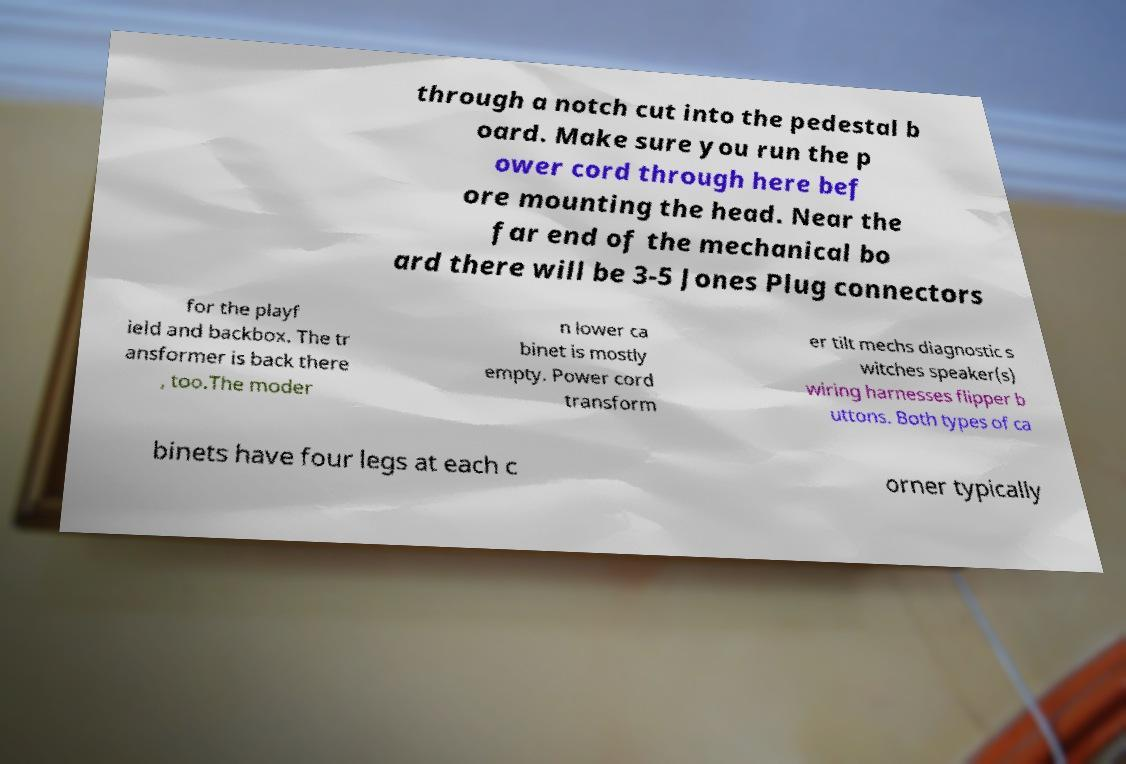Please identify and transcribe the text found in this image. through a notch cut into the pedestal b oard. Make sure you run the p ower cord through here bef ore mounting the head. Near the far end of the mechanical bo ard there will be 3-5 Jones Plug connectors for the playf ield and backbox. The tr ansformer is back there , too.The moder n lower ca binet is mostly empty. Power cord transform er tilt mechs diagnostic s witches speaker(s) wiring harnesses flipper b uttons. Both types of ca binets have four legs at each c orner typically 